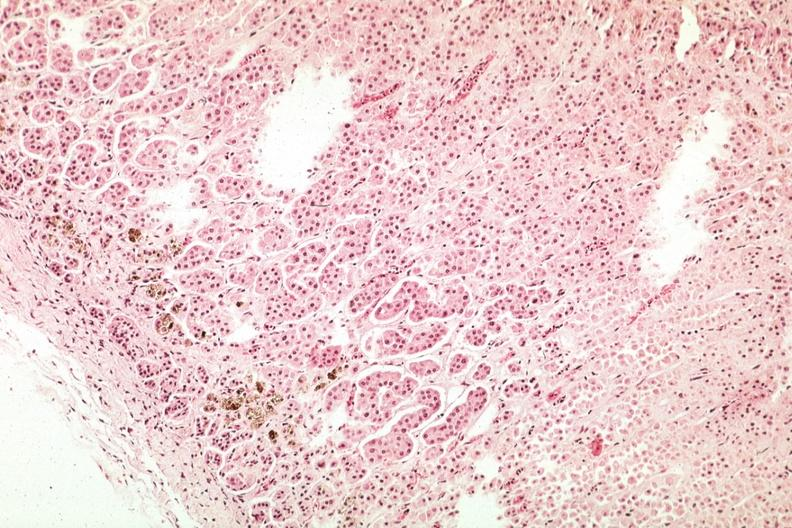does this image show pigment in area of zona glomerulosa?
Answer the question using a single word or phrase. Yes 